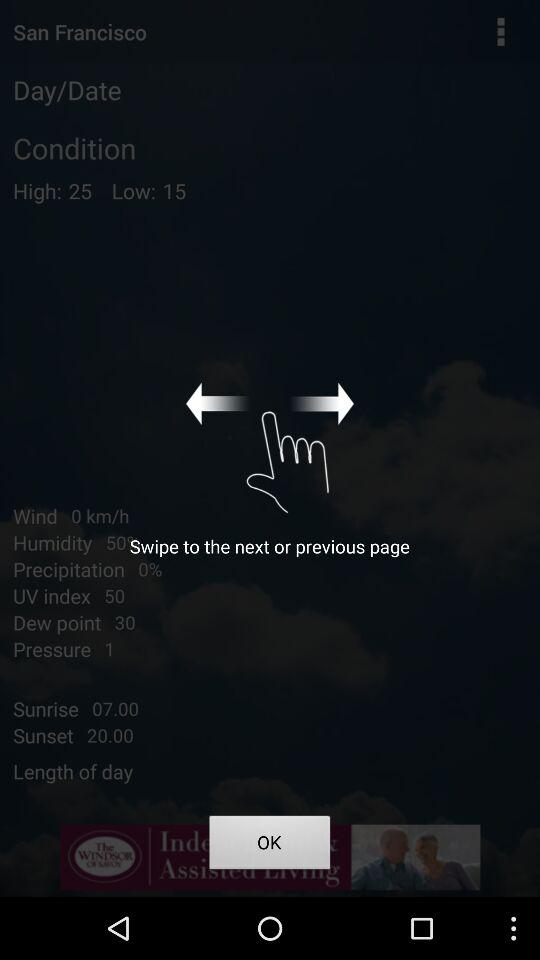What is the difference between the high and low temperatures?
Answer the question using a single word or phrase. 10 